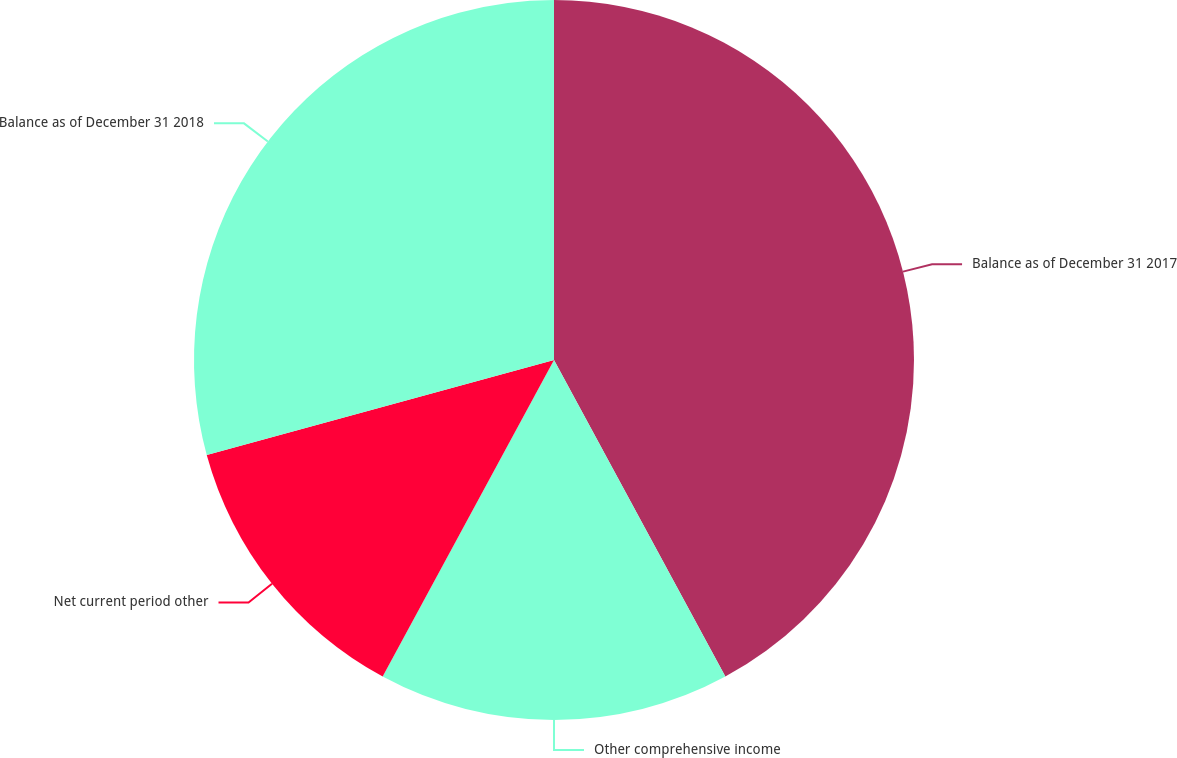<chart> <loc_0><loc_0><loc_500><loc_500><pie_chart><fcel>Balance as of December 31 2017<fcel>Other comprehensive income<fcel>Net current period other<fcel>Balance as of December 31 2018<nl><fcel>42.11%<fcel>15.79%<fcel>12.86%<fcel>29.25%<nl></chart> 